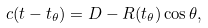<formula> <loc_0><loc_0><loc_500><loc_500>c ( t - t _ { \theta } ) = D - R ( t _ { \theta } ) \cos \theta ,</formula> 